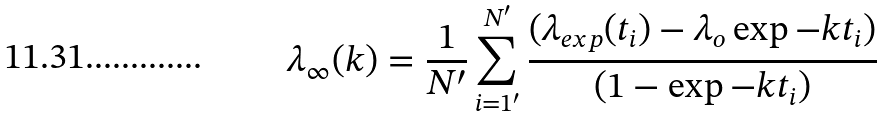Convert formula to latex. <formula><loc_0><loc_0><loc_500><loc_500>\lambda _ { \infty } ( k ) = \frac { 1 } { N ^ { \prime } } \sum _ { i = 1 ^ { \prime } } ^ { N ^ { \prime } } \frac { ( \lambda _ { e x p } ( t _ { i } ) - \lambda _ { o } \exp { - k t _ { i } } ) } { ( 1 - \exp { - k t _ { i } } ) }</formula> 